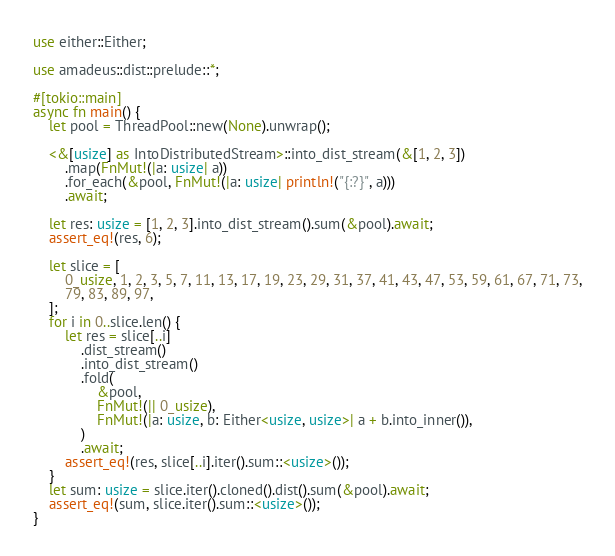Convert code to text. <code><loc_0><loc_0><loc_500><loc_500><_Rust_>use either::Either;

use amadeus::dist::prelude::*;

#[tokio::main]
async fn main() {
	let pool = ThreadPool::new(None).unwrap();

	<&[usize] as IntoDistributedStream>::into_dist_stream(&[1, 2, 3])
		.map(FnMut!(|a: usize| a))
		.for_each(&pool, FnMut!(|a: usize| println!("{:?}", a)))
		.await;

	let res: usize = [1, 2, 3].into_dist_stream().sum(&pool).await;
	assert_eq!(res, 6);

	let slice = [
		0_usize, 1, 2, 3, 5, 7, 11, 13, 17, 19, 23, 29, 31, 37, 41, 43, 47, 53, 59, 61, 67, 71, 73,
		79, 83, 89, 97,
	];
	for i in 0..slice.len() {
		let res = slice[..i]
			.dist_stream()
			.into_dist_stream()
			.fold(
				&pool,
				FnMut!(|| 0_usize),
				FnMut!(|a: usize, b: Either<usize, usize>| a + b.into_inner()),
			)
			.await;
		assert_eq!(res, slice[..i].iter().sum::<usize>());
	}
	let sum: usize = slice.iter().cloned().dist().sum(&pool).await;
	assert_eq!(sum, slice.iter().sum::<usize>());
}
</code> 